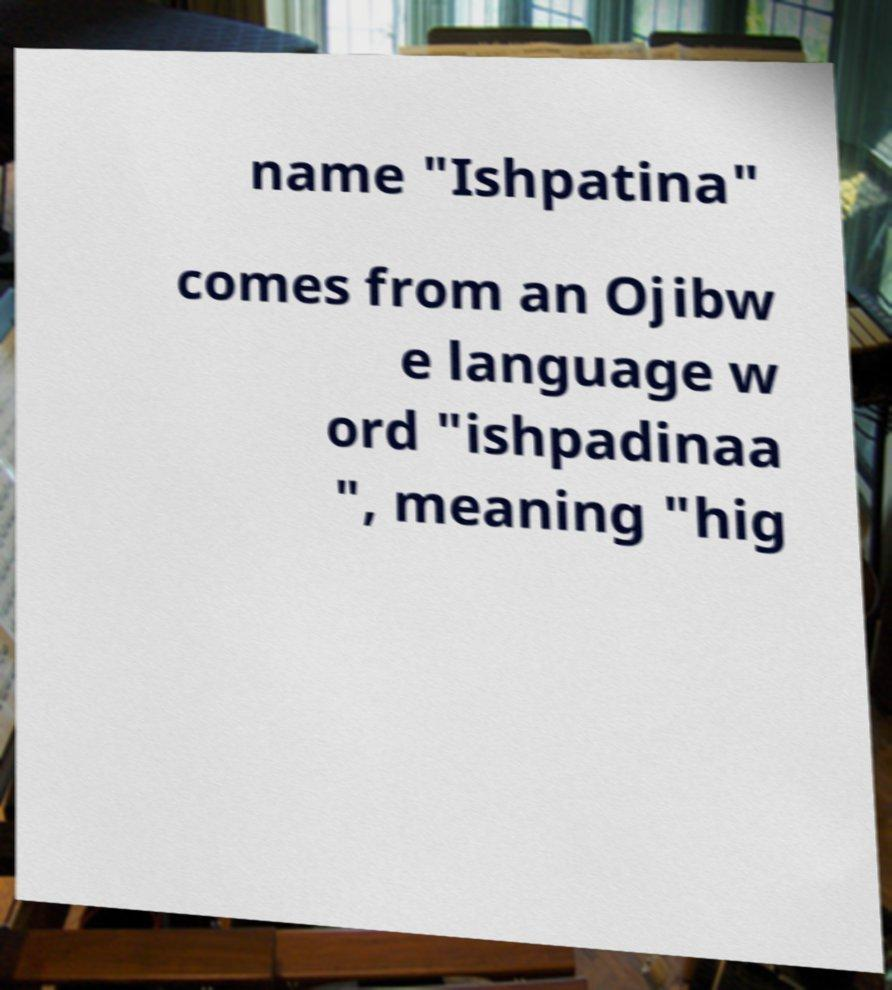Could you assist in decoding the text presented in this image and type it out clearly? name "Ishpatina" comes from an Ojibw e language w ord "ishpadinaa ", meaning "hig 